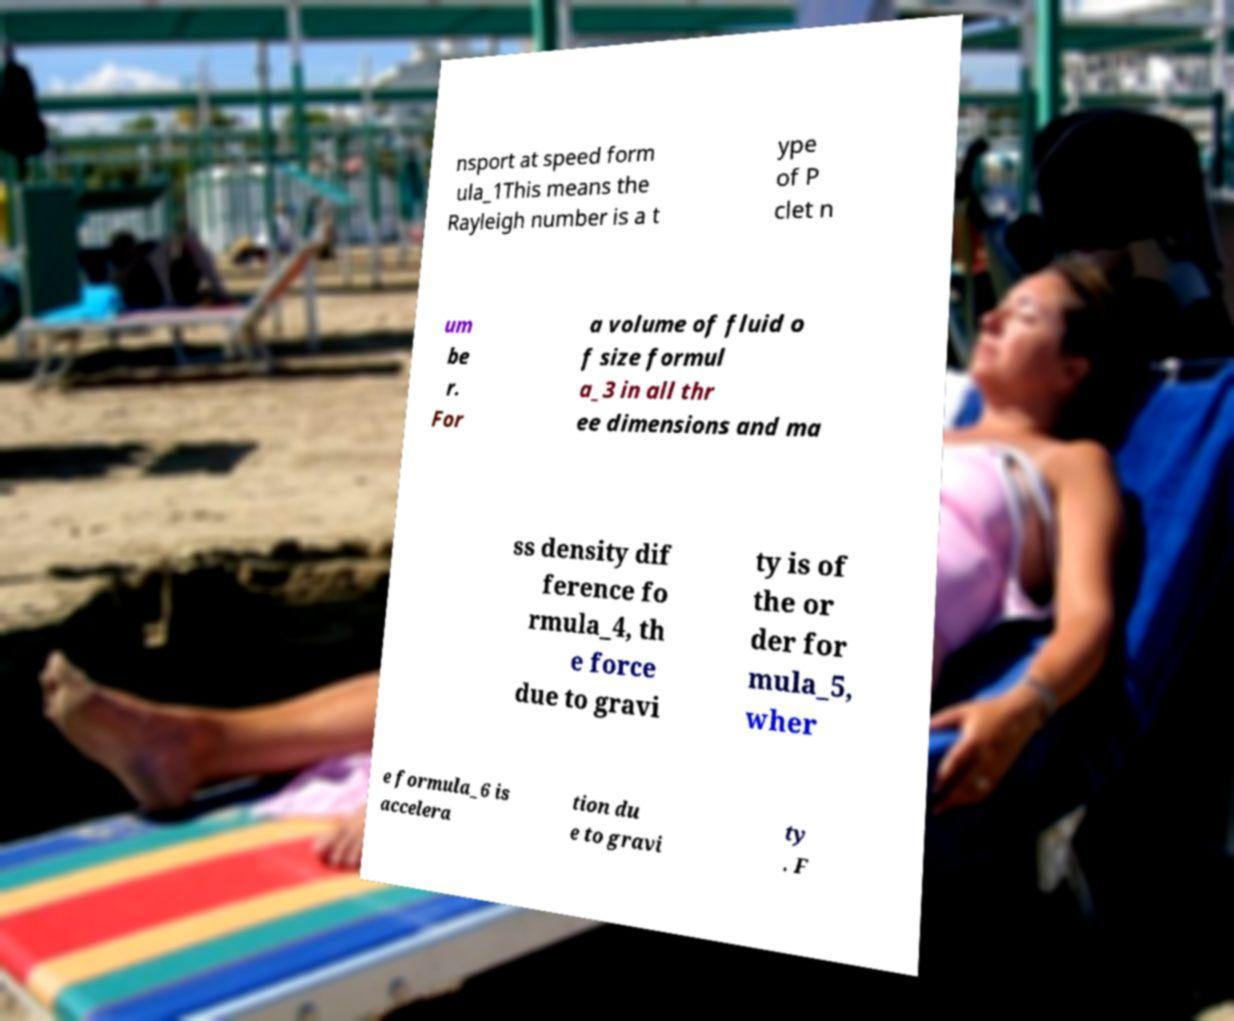Please identify and transcribe the text found in this image. nsport at speed form ula_1This means the Rayleigh number is a t ype of P clet n um be r. For a volume of fluid o f size formul a_3 in all thr ee dimensions and ma ss density dif ference fo rmula_4, th e force due to gravi ty is of the or der for mula_5, wher e formula_6 is accelera tion du e to gravi ty . F 